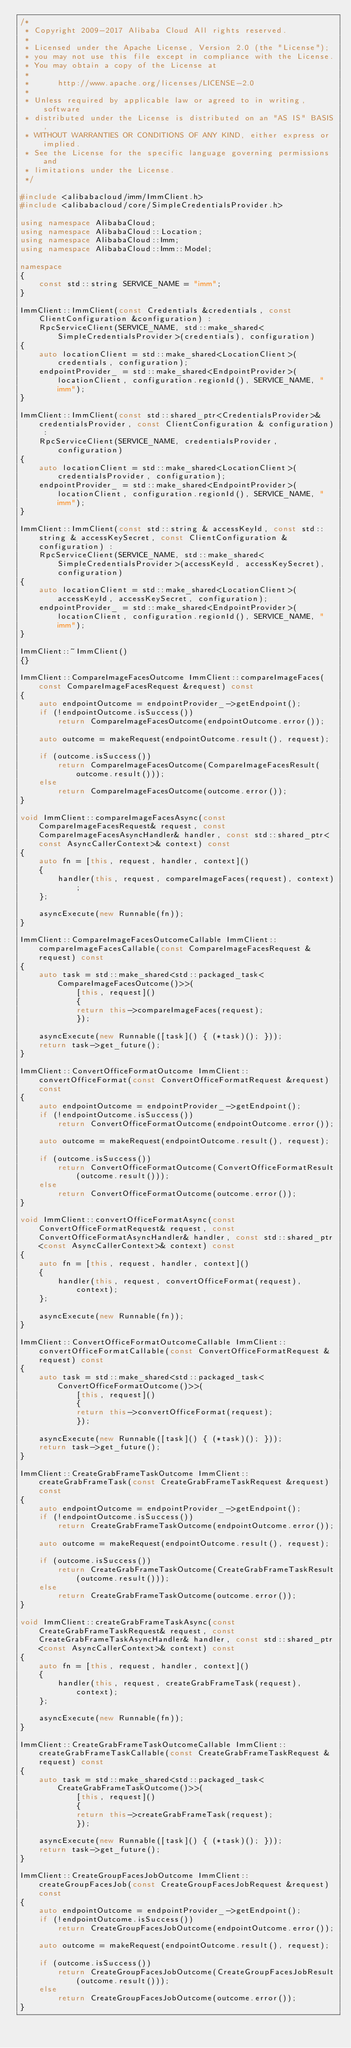<code> <loc_0><loc_0><loc_500><loc_500><_C++_>/*
 * Copyright 2009-2017 Alibaba Cloud All rights reserved.
 * 
 * Licensed under the Apache License, Version 2.0 (the "License");
 * you may not use this file except in compliance with the License.
 * You may obtain a copy of the License at
 * 
 *      http://www.apache.org/licenses/LICENSE-2.0
 * 
 * Unless required by applicable law or agreed to in writing, software
 * distributed under the License is distributed on an "AS IS" BASIS,
 * WITHOUT WARRANTIES OR CONDITIONS OF ANY KIND, either express or implied.
 * See the License for the specific language governing permissions and
 * limitations under the License.
 */

#include <alibabacloud/imm/ImmClient.h>
#include <alibabacloud/core/SimpleCredentialsProvider.h>

using namespace AlibabaCloud;
using namespace AlibabaCloud::Location;
using namespace AlibabaCloud::Imm;
using namespace AlibabaCloud::Imm::Model;

namespace
{
	const std::string SERVICE_NAME = "imm";
}

ImmClient::ImmClient(const Credentials &credentials, const ClientConfiguration &configuration) :
	RpcServiceClient(SERVICE_NAME, std::make_shared<SimpleCredentialsProvider>(credentials), configuration)
{
	auto locationClient = std::make_shared<LocationClient>(credentials, configuration);
	endpointProvider_ = std::make_shared<EndpointProvider>(locationClient, configuration.regionId(), SERVICE_NAME, "imm");
}

ImmClient::ImmClient(const std::shared_ptr<CredentialsProvider>& credentialsProvider, const ClientConfiguration & configuration) :
	RpcServiceClient(SERVICE_NAME, credentialsProvider, configuration)
{
	auto locationClient = std::make_shared<LocationClient>(credentialsProvider, configuration);
	endpointProvider_ = std::make_shared<EndpointProvider>(locationClient, configuration.regionId(), SERVICE_NAME, "imm");
}

ImmClient::ImmClient(const std::string & accessKeyId, const std::string & accessKeySecret, const ClientConfiguration & configuration) :
	RpcServiceClient(SERVICE_NAME, std::make_shared<SimpleCredentialsProvider>(accessKeyId, accessKeySecret), configuration)
{
	auto locationClient = std::make_shared<LocationClient>(accessKeyId, accessKeySecret, configuration);
	endpointProvider_ = std::make_shared<EndpointProvider>(locationClient, configuration.regionId(), SERVICE_NAME, "imm");
}

ImmClient::~ImmClient()
{}

ImmClient::CompareImageFacesOutcome ImmClient::compareImageFaces(const CompareImageFacesRequest &request) const
{
	auto endpointOutcome = endpointProvider_->getEndpoint();
	if (!endpointOutcome.isSuccess())
		return CompareImageFacesOutcome(endpointOutcome.error());

	auto outcome = makeRequest(endpointOutcome.result(), request);

	if (outcome.isSuccess())
		return CompareImageFacesOutcome(CompareImageFacesResult(outcome.result()));
	else
		return CompareImageFacesOutcome(outcome.error());
}

void ImmClient::compareImageFacesAsync(const CompareImageFacesRequest& request, const CompareImageFacesAsyncHandler& handler, const std::shared_ptr<const AsyncCallerContext>& context) const
{
	auto fn = [this, request, handler, context]()
	{
		handler(this, request, compareImageFaces(request), context);
	};

	asyncExecute(new Runnable(fn));
}

ImmClient::CompareImageFacesOutcomeCallable ImmClient::compareImageFacesCallable(const CompareImageFacesRequest &request) const
{
	auto task = std::make_shared<std::packaged_task<CompareImageFacesOutcome()>>(
			[this, request]()
			{
			return this->compareImageFaces(request);
			});

	asyncExecute(new Runnable([task]() { (*task)(); }));
	return task->get_future();
}

ImmClient::ConvertOfficeFormatOutcome ImmClient::convertOfficeFormat(const ConvertOfficeFormatRequest &request) const
{
	auto endpointOutcome = endpointProvider_->getEndpoint();
	if (!endpointOutcome.isSuccess())
		return ConvertOfficeFormatOutcome(endpointOutcome.error());

	auto outcome = makeRequest(endpointOutcome.result(), request);

	if (outcome.isSuccess())
		return ConvertOfficeFormatOutcome(ConvertOfficeFormatResult(outcome.result()));
	else
		return ConvertOfficeFormatOutcome(outcome.error());
}

void ImmClient::convertOfficeFormatAsync(const ConvertOfficeFormatRequest& request, const ConvertOfficeFormatAsyncHandler& handler, const std::shared_ptr<const AsyncCallerContext>& context) const
{
	auto fn = [this, request, handler, context]()
	{
		handler(this, request, convertOfficeFormat(request), context);
	};

	asyncExecute(new Runnable(fn));
}

ImmClient::ConvertOfficeFormatOutcomeCallable ImmClient::convertOfficeFormatCallable(const ConvertOfficeFormatRequest &request) const
{
	auto task = std::make_shared<std::packaged_task<ConvertOfficeFormatOutcome()>>(
			[this, request]()
			{
			return this->convertOfficeFormat(request);
			});

	asyncExecute(new Runnable([task]() { (*task)(); }));
	return task->get_future();
}

ImmClient::CreateGrabFrameTaskOutcome ImmClient::createGrabFrameTask(const CreateGrabFrameTaskRequest &request) const
{
	auto endpointOutcome = endpointProvider_->getEndpoint();
	if (!endpointOutcome.isSuccess())
		return CreateGrabFrameTaskOutcome(endpointOutcome.error());

	auto outcome = makeRequest(endpointOutcome.result(), request);

	if (outcome.isSuccess())
		return CreateGrabFrameTaskOutcome(CreateGrabFrameTaskResult(outcome.result()));
	else
		return CreateGrabFrameTaskOutcome(outcome.error());
}

void ImmClient::createGrabFrameTaskAsync(const CreateGrabFrameTaskRequest& request, const CreateGrabFrameTaskAsyncHandler& handler, const std::shared_ptr<const AsyncCallerContext>& context) const
{
	auto fn = [this, request, handler, context]()
	{
		handler(this, request, createGrabFrameTask(request), context);
	};

	asyncExecute(new Runnable(fn));
}

ImmClient::CreateGrabFrameTaskOutcomeCallable ImmClient::createGrabFrameTaskCallable(const CreateGrabFrameTaskRequest &request) const
{
	auto task = std::make_shared<std::packaged_task<CreateGrabFrameTaskOutcome()>>(
			[this, request]()
			{
			return this->createGrabFrameTask(request);
			});

	asyncExecute(new Runnable([task]() { (*task)(); }));
	return task->get_future();
}

ImmClient::CreateGroupFacesJobOutcome ImmClient::createGroupFacesJob(const CreateGroupFacesJobRequest &request) const
{
	auto endpointOutcome = endpointProvider_->getEndpoint();
	if (!endpointOutcome.isSuccess())
		return CreateGroupFacesJobOutcome(endpointOutcome.error());

	auto outcome = makeRequest(endpointOutcome.result(), request);

	if (outcome.isSuccess())
		return CreateGroupFacesJobOutcome(CreateGroupFacesJobResult(outcome.result()));
	else
		return CreateGroupFacesJobOutcome(outcome.error());
}
</code> 